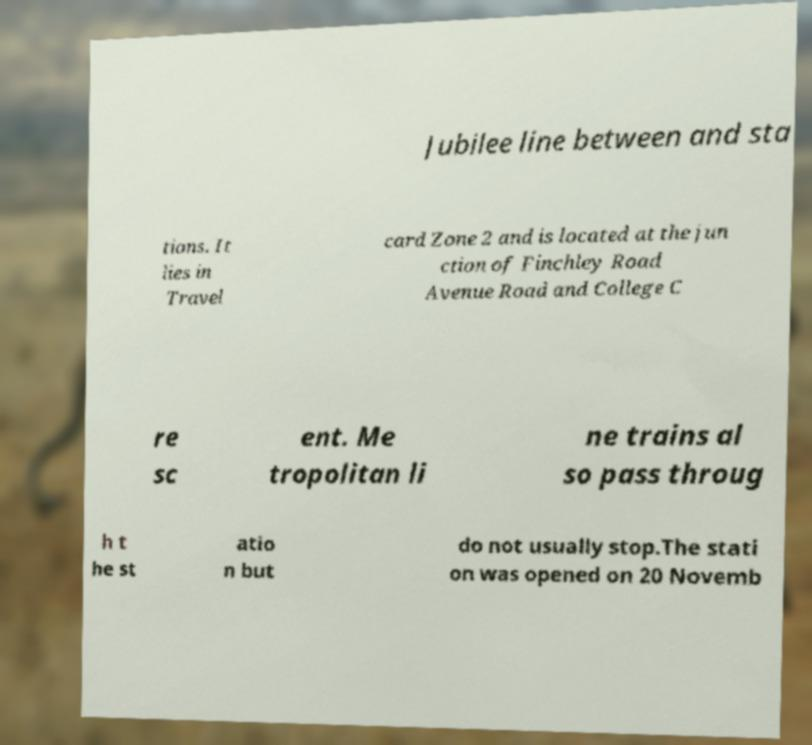There's text embedded in this image that I need extracted. Can you transcribe it verbatim? Jubilee line between and sta tions. It lies in Travel card Zone 2 and is located at the jun ction of Finchley Road Avenue Road and College C re sc ent. Me tropolitan li ne trains al so pass throug h t he st atio n but do not usually stop.The stati on was opened on 20 Novemb 